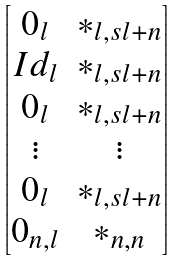Convert formula to latex. <formula><loc_0><loc_0><loc_500><loc_500>\begin{bmatrix} 0 _ { l } & * _ { l , s l + n } \\ I d _ { l } & * _ { l , s l + n } \\ 0 _ { l } & * _ { l , s l + n } \\ \vdots & \vdots \\ 0 _ { l } & * _ { l , s l + n } \\ 0 _ { n , l } & * _ { n , n } \end{bmatrix}</formula> 